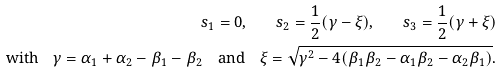Convert formula to latex. <formula><loc_0><loc_0><loc_500><loc_500>s _ { 1 } = 0 , \quad s _ { 2 } = \frac { 1 } { 2 } ( \gamma - \xi ) , \quad s _ { 3 } = \frac { 1 } { 2 } ( \gamma + \xi ) \\ \text {with} \quad \gamma = \alpha _ { 1 } + \alpha _ { 2 } - \beta _ { 1 } - \beta _ { 2 } \quad \text {and} \quad \xi = \sqrt { \gamma ^ { 2 } - 4 ( \beta _ { 1 } \beta _ { 2 } - \alpha _ { 1 } \beta _ { 2 } - \alpha _ { 2 } \beta _ { 1 } ) } .</formula> 